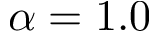<formula> <loc_0><loc_0><loc_500><loc_500>\alpha = 1 . 0</formula> 